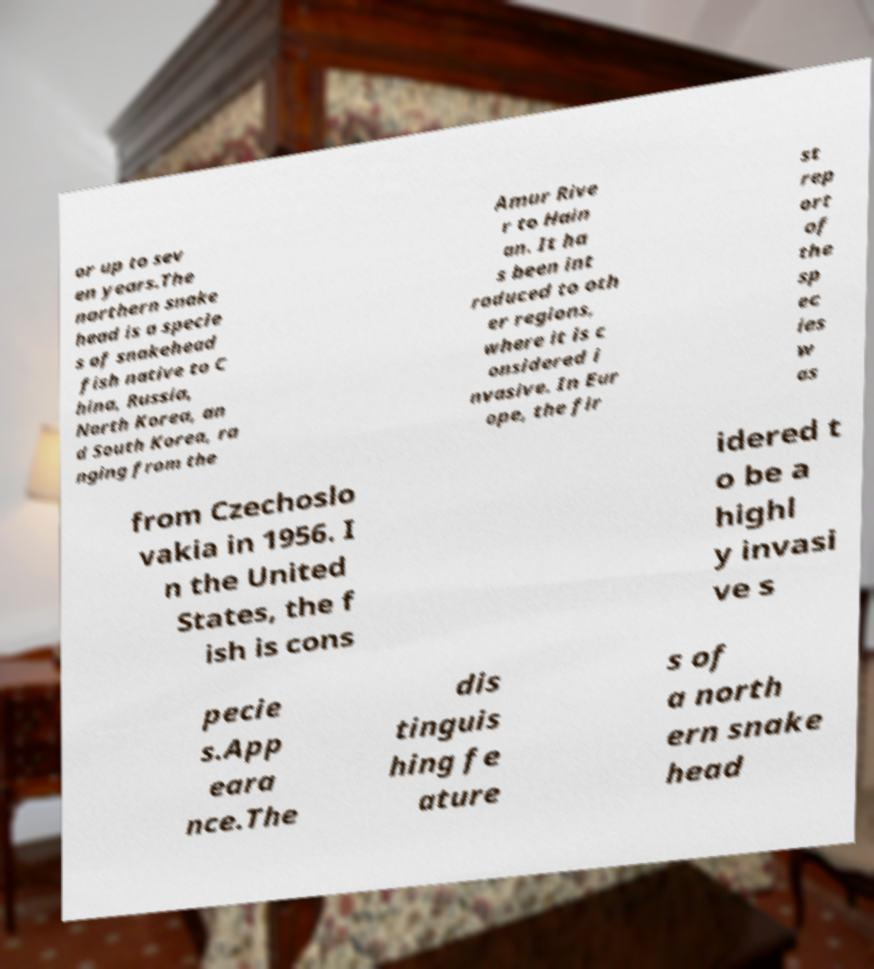There's text embedded in this image that I need extracted. Can you transcribe it verbatim? or up to sev en years.The northern snake head is a specie s of snakehead fish native to C hina, Russia, North Korea, an d South Korea, ra nging from the Amur Rive r to Hain an. It ha s been int roduced to oth er regions, where it is c onsidered i nvasive. In Eur ope, the fir st rep ort of the sp ec ies w as from Czechoslo vakia in 1956. I n the United States, the f ish is cons idered t o be a highl y invasi ve s pecie s.App eara nce.The dis tinguis hing fe ature s of a north ern snake head 